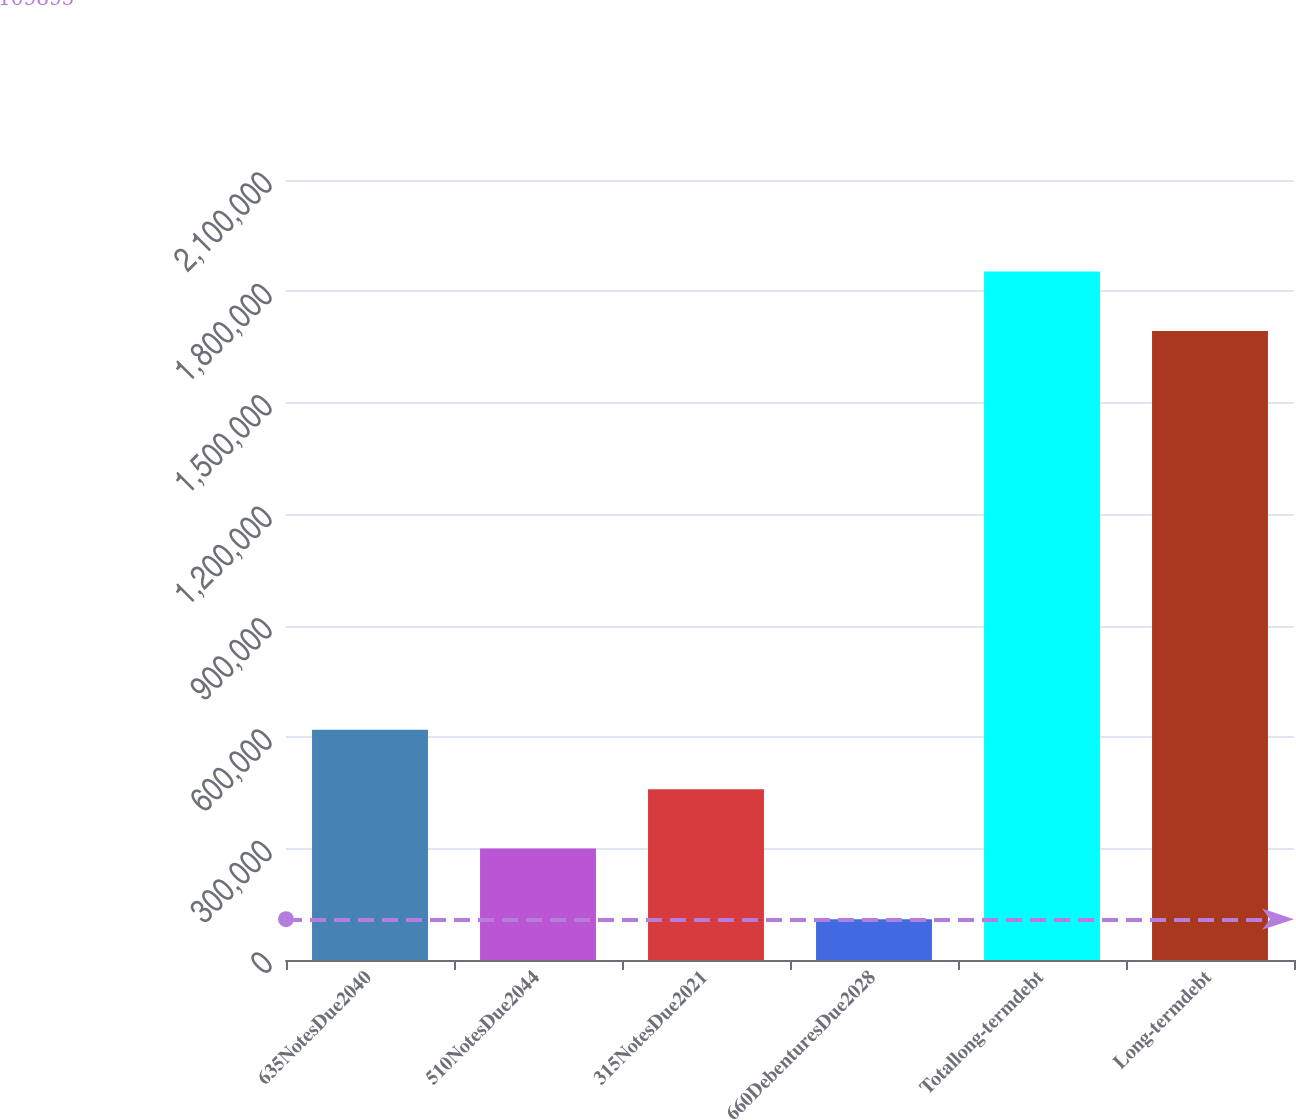Convert chart. <chart><loc_0><loc_0><loc_500><loc_500><bar_chart><fcel>635NotesDue2040<fcel>510NotesDue2044<fcel>315NotesDue2021<fcel>660DebenturesDue2028<fcel>Totallong-termdebt<fcel>Long-termdebt<nl><fcel>620000<fcel>300000<fcel>460000<fcel>109895<fcel>1.85361e+06<fcel>1.69361e+06<nl></chart> 